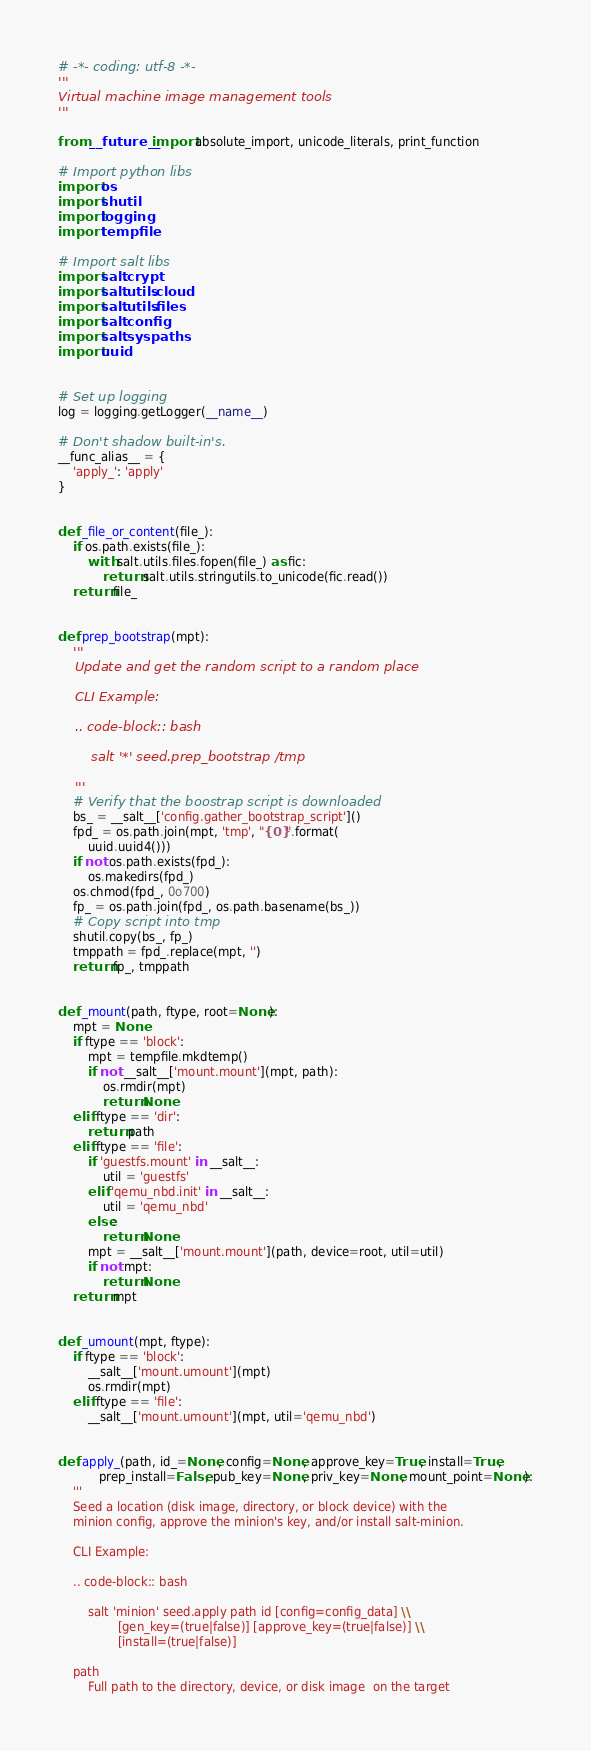Convert code to text. <code><loc_0><loc_0><loc_500><loc_500><_Python_># -*- coding: utf-8 -*-
'''
Virtual machine image management tools
'''

from __future__ import absolute_import, unicode_literals, print_function

# Import python libs
import os
import shutil
import logging
import tempfile

# Import salt libs
import salt.crypt
import salt.utils.cloud
import salt.utils.files
import salt.config
import salt.syspaths
import uuid


# Set up logging
log = logging.getLogger(__name__)

# Don't shadow built-in's.
__func_alias__ = {
    'apply_': 'apply'
}


def _file_or_content(file_):
    if os.path.exists(file_):
        with salt.utils.files.fopen(file_) as fic:
            return salt.utils.stringutils.to_unicode(fic.read())
    return file_


def prep_bootstrap(mpt):
    '''
    Update and get the random script to a random place

    CLI Example:

    .. code-block:: bash

        salt '*' seed.prep_bootstrap /tmp

    '''
    # Verify that the boostrap script is downloaded
    bs_ = __salt__['config.gather_bootstrap_script']()
    fpd_ = os.path.join(mpt, 'tmp', "{0}".format(
        uuid.uuid4()))
    if not os.path.exists(fpd_):
        os.makedirs(fpd_)
    os.chmod(fpd_, 0o700)
    fp_ = os.path.join(fpd_, os.path.basename(bs_))
    # Copy script into tmp
    shutil.copy(bs_, fp_)
    tmppath = fpd_.replace(mpt, '')
    return fp_, tmppath


def _mount(path, ftype, root=None):
    mpt = None
    if ftype == 'block':
        mpt = tempfile.mkdtemp()
        if not __salt__['mount.mount'](mpt, path):
            os.rmdir(mpt)
            return None
    elif ftype == 'dir':
        return path
    elif ftype == 'file':
        if 'guestfs.mount' in __salt__:
            util = 'guestfs'
        elif 'qemu_nbd.init' in __salt__:
            util = 'qemu_nbd'
        else:
            return None
        mpt = __salt__['mount.mount'](path, device=root, util=util)
        if not mpt:
            return None
    return mpt


def _umount(mpt, ftype):
    if ftype == 'block':
        __salt__['mount.umount'](mpt)
        os.rmdir(mpt)
    elif ftype == 'file':
        __salt__['mount.umount'](mpt, util='qemu_nbd')


def apply_(path, id_=None, config=None, approve_key=True, install=True,
           prep_install=False, pub_key=None, priv_key=None, mount_point=None):
    '''
    Seed a location (disk image, directory, or block device) with the
    minion config, approve the minion's key, and/or install salt-minion.

    CLI Example:

    .. code-block:: bash

        salt 'minion' seed.apply path id [config=config_data] \\
                [gen_key=(true|false)] [approve_key=(true|false)] \\
                [install=(true|false)]

    path
        Full path to the directory, device, or disk image  on the target</code> 